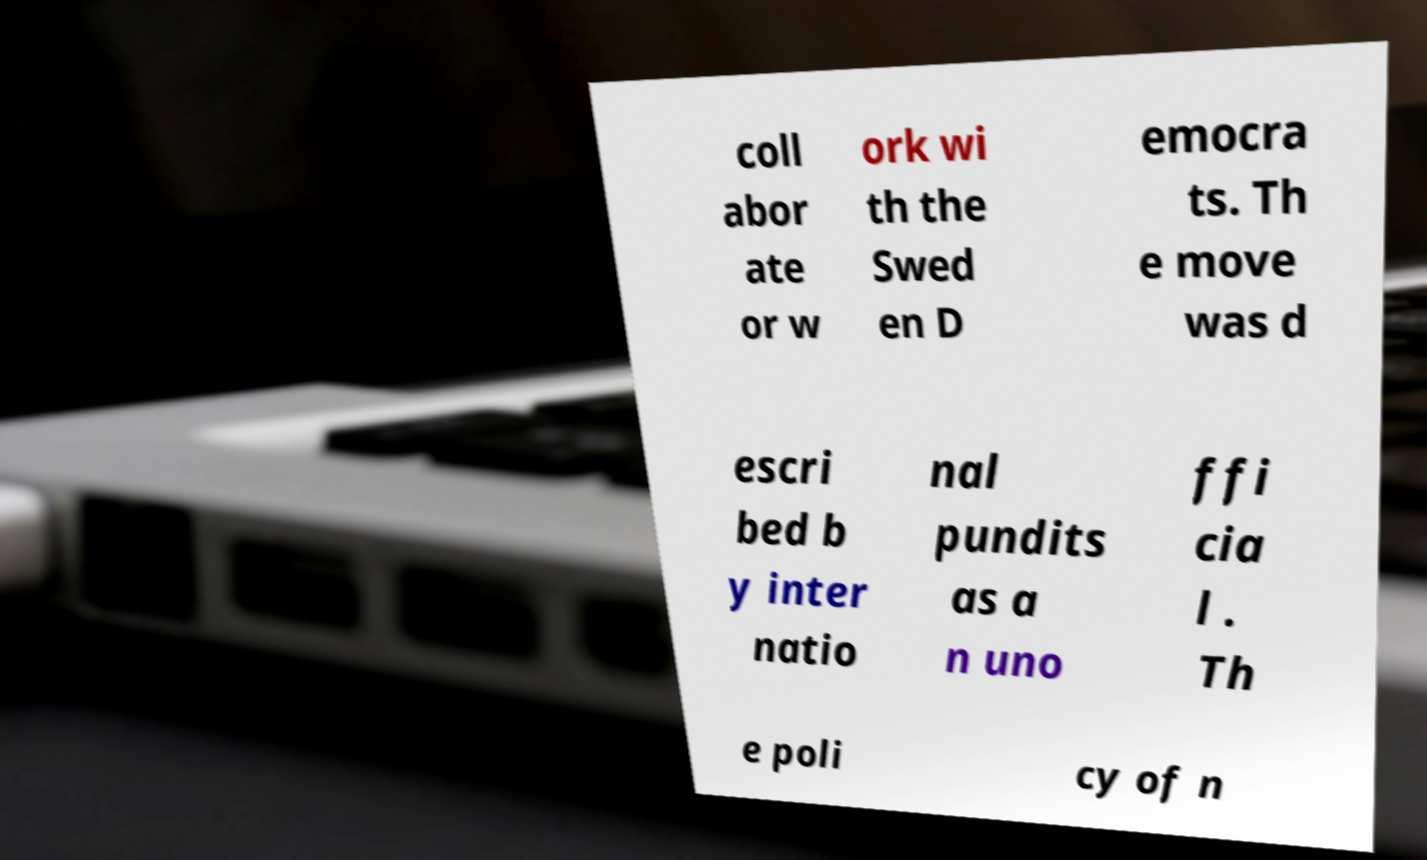I need the written content from this picture converted into text. Can you do that? coll abor ate or w ork wi th the Swed en D emocra ts. Th e move was d escri bed b y inter natio nal pundits as a n uno ffi cia l . Th e poli cy of n 